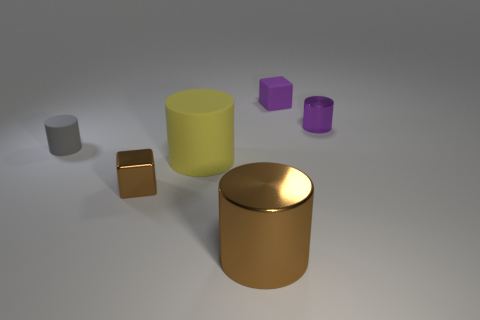What color is the object that is both to the left of the big yellow matte cylinder and behind the tiny brown cube?
Give a very brief answer. Gray. What number of yellow metal spheres have the same size as the gray rubber cylinder?
Your answer should be very brief. 0. What shape is the matte thing on the right side of the big thing that is in front of the yellow matte thing?
Your answer should be compact. Cube. What shape is the purple thing that is on the left side of the purple thing in front of the tiny matte object that is behind the tiny shiny cylinder?
Offer a very short reply. Cube. What number of other big rubber things have the same shape as the gray rubber thing?
Your answer should be very brief. 1. How many gray matte objects are on the right side of the big cylinder that is on the right side of the yellow thing?
Your response must be concise. 0. What number of metallic objects are large cylinders or small brown cubes?
Provide a short and direct response. 2. Are there any small purple cylinders made of the same material as the yellow cylinder?
Provide a succinct answer. No. What number of objects are either tiny metallic cylinders right of the gray cylinder or rubber objects right of the big metal cylinder?
Give a very brief answer. 2. Do the tiny metal thing that is on the left side of the small matte block and the large metal cylinder have the same color?
Provide a short and direct response. Yes. 